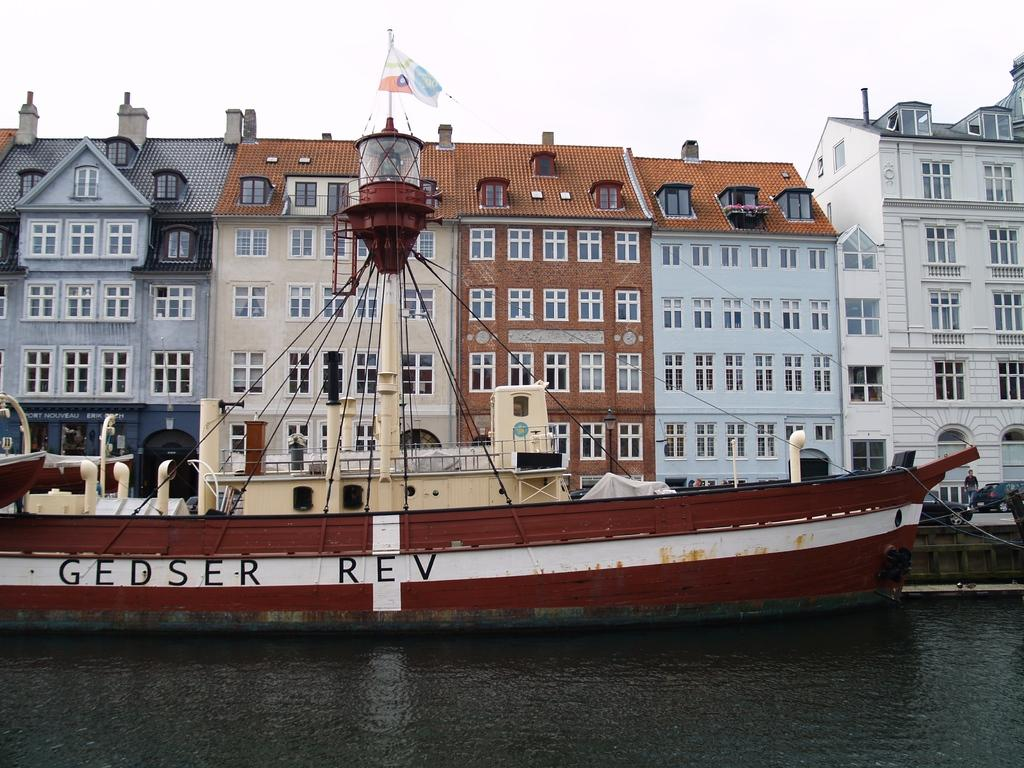What is the main feature of the image? There is water in the image. What is floating on the water? There is a boat in the image. What can be seen on the boat? There is a flag in the image. What other objects are present in the image? There are vehicles and buildings in the image. Is there any human presence in the image? Yes, there is a person in the image. What can be seen in the background of the image? The sky is visible in the background of the image. What type of powder is being used to smash the rake in the image? There is no rake or powder present in the image. How does the person in the image use the powder to smash the rake? There is no rake or powder in the image, so this action cannot be observed. 